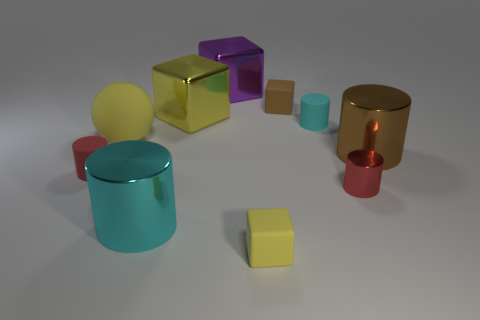What is the material of the other small thing that is the same shape as the brown matte object?
Your answer should be very brief. Rubber. The tiny red thing on the right side of the small red thing behind the small red shiny object is what shape?
Offer a very short reply. Cylinder. Does the red object to the left of the large yellow rubber object have the same material as the large cyan cylinder?
Offer a very short reply. No. Are there an equal number of big yellow blocks that are left of the small red matte cylinder and matte things to the right of the large cyan metal cylinder?
Provide a short and direct response. No. There is a small cube that is the same color as the large matte sphere; what is it made of?
Make the answer very short. Rubber. How many red objects are right of the small rubber object left of the large rubber ball?
Your response must be concise. 1. There is a matte cylinder that is in front of the tiny cyan matte thing; is it the same color as the large object that is to the left of the large cyan metal object?
Your answer should be compact. No. There is a purple cube that is the same size as the yellow shiny block; what is its material?
Provide a succinct answer. Metal. What is the shape of the small red thing that is in front of the red thing that is to the left of the yellow matte object to the right of the large cyan metallic object?
Keep it short and to the point. Cylinder. What shape is the matte object that is the same size as the cyan metallic cylinder?
Your answer should be compact. Sphere. 